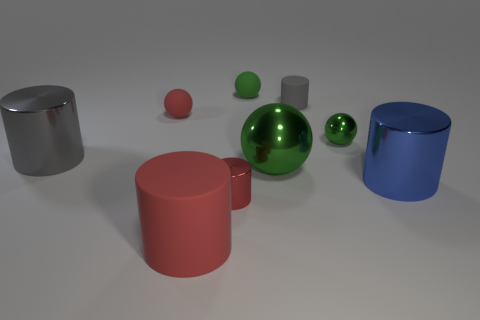How many green balls must be subtracted to get 1 green balls? 2 Subtract all yellow blocks. How many green spheres are left? 3 Subtract all purple spheres. Subtract all yellow cylinders. How many spheres are left? 4 Add 1 red matte objects. How many objects exist? 10 Subtract all cylinders. How many objects are left? 4 Add 2 tiny red shiny cylinders. How many tiny red shiny cylinders exist? 3 Subtract 0 red cubes. How many objects are left? 9 Subtract all big green metallic spheres. Subtract all gray cylinders. How many objects are left? 6 Add 1 small gray rubber cylinders. How many small gray rubber cylinders are left? 2 